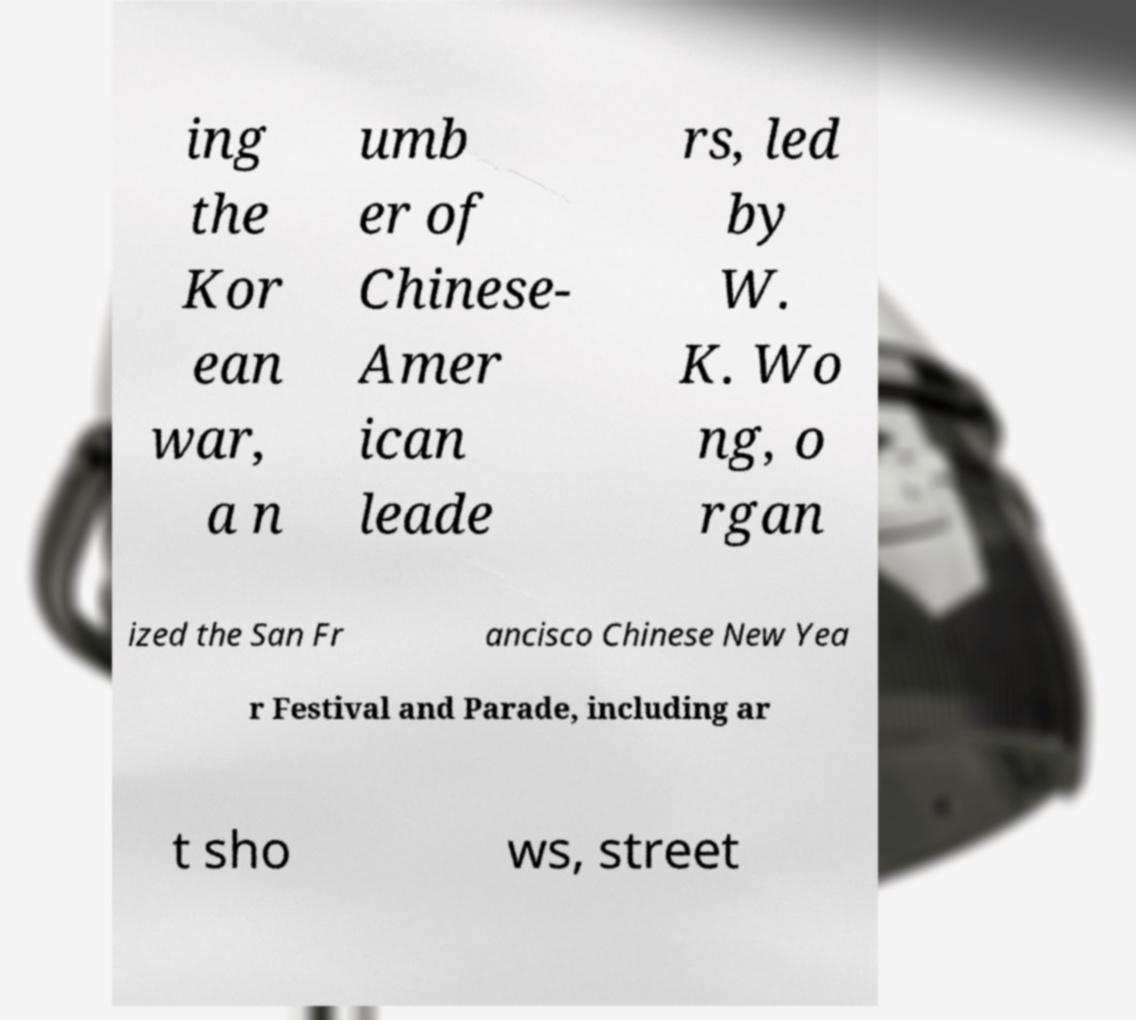Can you read and provide the text displayed in the image?This photo seems to have some interesting text. Can you extract and type it out for me? ing the Kor ean war, a n umb er of Chinese- Amer ican leade rs, led by W. K. Wo ng, o rgan ized the San Fr ancisco Chinese New Yea r Festival and Parade, including ar t sho ws, street 